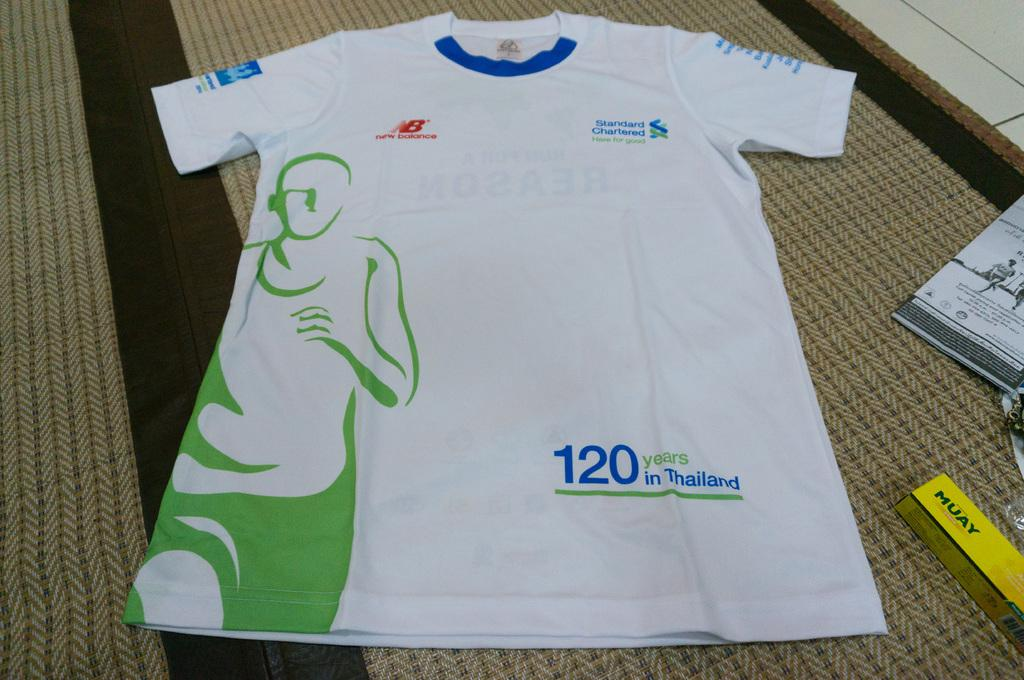<image>
Write a terse but informative summary of the picture. A tshirt that says 120 years in Thailand. 